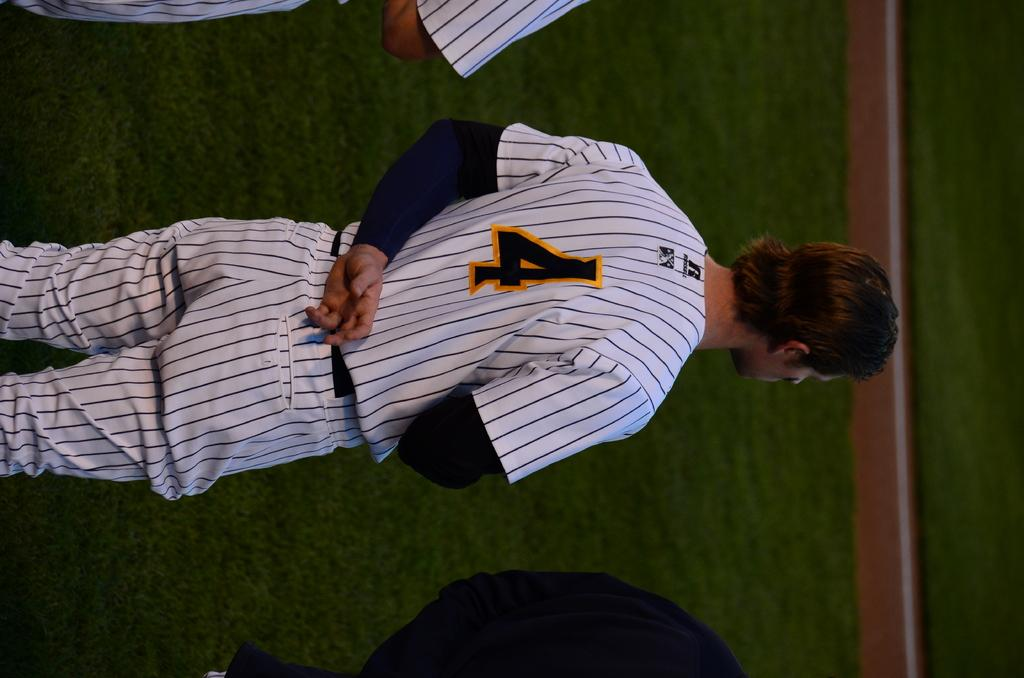<image>
Offer a succinct explanation of the picture presented. A player wearing a black and white striped shirt with the number 4 on the back. 